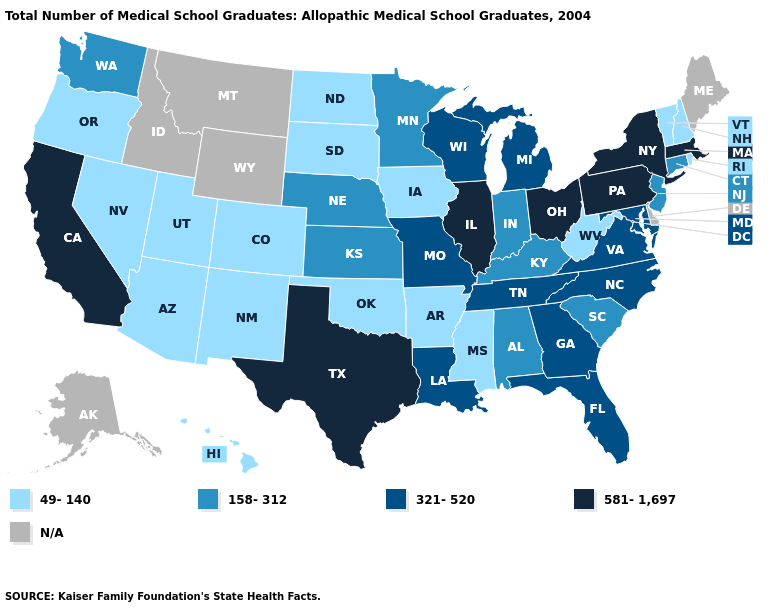What is the lowest value in the South?
Write a very short answer. 49-140. What is the value of South Dakota?
Give a very brief answer. 49-140. Which states have the lowest value in the South?
Quick response, please. Arkansas, Mississippi, Oklahoma, West Virginia. Is the legend a continuous bar?
Write a very short answer. No. Which states hav the highest value in the Northeast?
Write a very short answer. Massachusetts, New York, Pennsylvania. Name the states that have a value in the range 321-520?
Write a very short answer. Florida, Georgia, Louisiana, Maryland, Michigan, Missouri, North Carolina, Tennessee, Virginia, Wisconsin. Name the states that have a value in the range 158-312?
Concise answer only. Alabama, Connecticut, Indiana, Kansas, Kentucky, Minnesota, Nebraska, New Jersey, South Carolina, Washington. What is the value of Delaware?
Answer briefly. N/A. Name the states that have a value in the range 581-1,697?
Short answer required. California, Illinois, Massachusetts, New York, Ohio, Pennsylvania, Texas. Name the states that have a value in the range 158-312?
Short answer required. Alabama, Connecticut, Indiana, Kansas, Kentucky, Minnesota, Nebraska, New Jersey, South Carolina, Washington. Which states have the lowest value in the West?
Keep it brief. Arizona, Colorado, Hawaii, Nevada, New Mexico, Oregon, Utah. Does the map have missing data?
Answer briefly. Yes. Does Connecticut have the lowest value in the Northeast?
Keep it brief. No. 